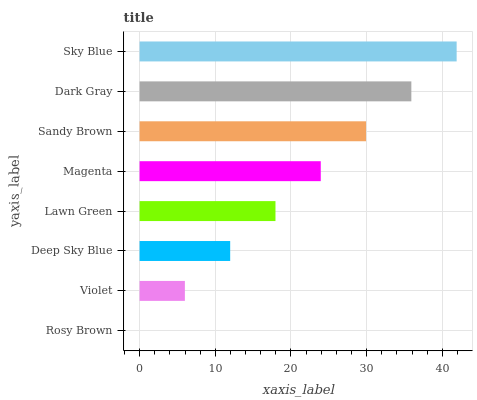Is Rosy Brown the minimum?
Answer yes or no. Yes. Is Sky Blue the maximum?
Answer yes or no. Yes. Is Violet the minimum?
Answer yes or no. No. Is Violet the maximum?
Answer yes or no. No. Is Violet greater than Rosy Brown?
Answer yes or no. Yes. Is Rosy Brown less than Violet?
Answer yes or no. Yes. Is Rosy Brown greater than Violet?
Answer yes or no. No. Is Violet less than Rosy Brown?
Answer yes or no. No. Is Magenta the high median?
Answer yes or no. Yes. Is Lawn Green the low median?
Answer yes or no. Yes. Is Lawn Green the high median?
Answer yes or no. No. Is Violet the low median?
Answer yes or no. No. 